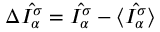Convert formula to latex. <formula><loc_0><loc_0><loc_500><loc_500>\Delta \hat { I _ { \alpha } ^ { \sigma } } = \hat { I _ { \alpha } ^ { \sigma } } - \langle \hat { I _ { \alpha } ^ { \sigma } } \rangle</formula> 